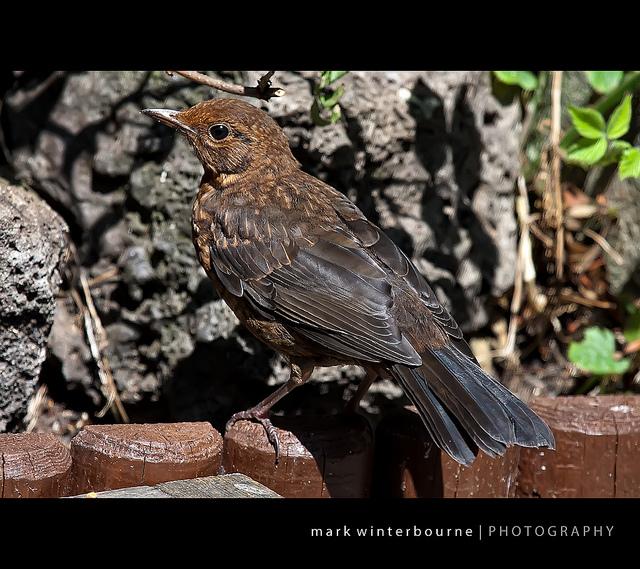Which direction is the bird facing?
Concise answer only. Left. How old is that bird?
Answer briefly. 2. What is this animal?
Be succinct. Bird. What type of bird is this?
Keep it brief. Finch. What is the bird sitting on?
Write a very short answer. Fence. Is there snow?
Give a very brief answer. No. Is the bird sitting on a fence?
Answer briefly. Yes. 